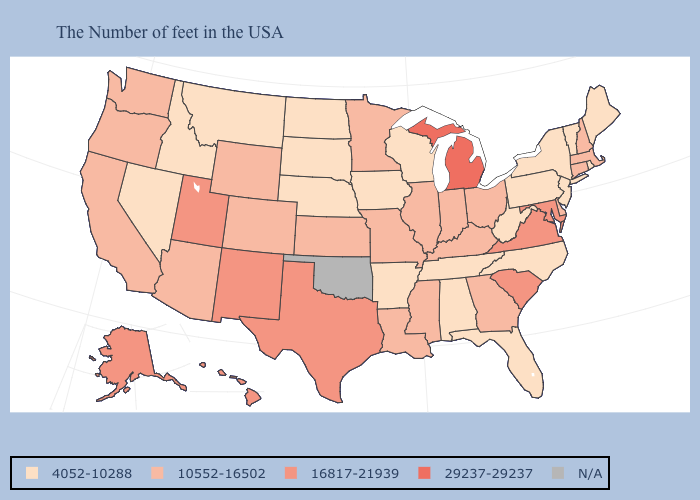Name the states that have a value in the range 29237-29237?
Answer briefly. Michigan. Name the states that have a value in the range 4052-10288?
Be succinct. Maine, Rhode Island, Vermont, New York, New Jersey, Pennsylvania, North Carolina, West Virginia, Florida, Alabama, Tennessee, Wisconsin, Arkansas, Iowa, Nebraska, South Dakota, North Dakota, Montana, Idaho, Nevada. Does Michigan have the highest value in the MidWest?
Short answer required. Yes. How many symbols are there in the legend?
Answer briefly. 5. Does Wisconsin have the highest value in the MidWest?
Keep it brief. No. Does the first symbol in the legend represent the smallest category?
Write a very short answer. Yes. What is the highest value in the USA?
Answer briefly. 29237-29237. Name the states that have a value in the range 16817-21939?
Answer briefly. Maryland, Virginia, South Carolina, Texas, New Mexico, Utah, Alaska, Hawaii. Name the states that have a value in the range N/A?
Be succinct. Oklahoma. Which states have the lowest value in the USA?
Keep it brief. Maine, Rhode Island, Vermont, New York, New Jersey, Pennsylvania, North Carolina, West Virginia, Florida, Alabama, Tennessee, Wisconsin, Arkansas, Iowa, Nebraska, South Dakota, North Dakota, Montana, Idaho, Nevada. Does Ohio have the highest value in the MidWest?
Concise answer only. No. What is the highest value in the West ?
Quick response, please. 16817-21939. What is the lowest value in the Northeast?
Short answer required. 4052-10288. Among the states that border Indiana , does Michigan have the highest value?
Give a very brief answer. Yes. What is the highest value in states that border New York?
Give a very brief answer. 10552-16502. 